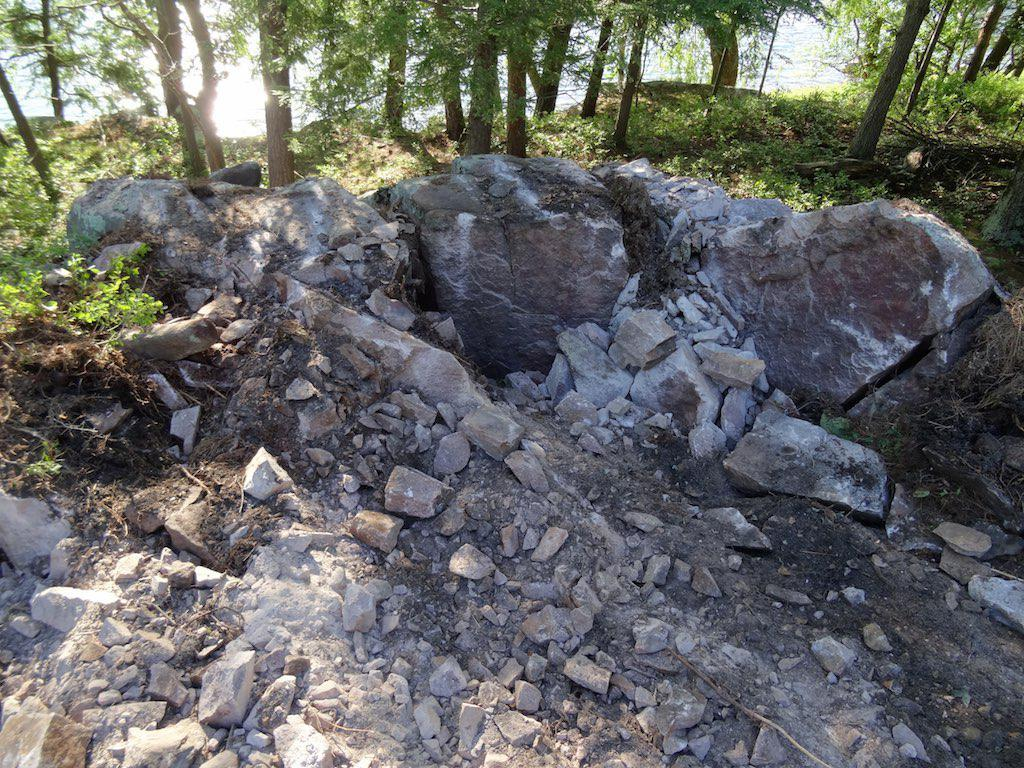What type of natural elements can be seen in the image? There are rocks, stones, trees, and water visible in the image. Can you describe the landscape in the image? The image features a landscape with rocks, stones, trees, and water. What type of vegetation is present in the image? Trees are present in the image. Where is the rabbit sitting in the image? There is no rabbit present in the image. What type of amusement can be seen in the image? There is no amusement present in the image; it features natural elements such as rocks, stones, trees, and water. 